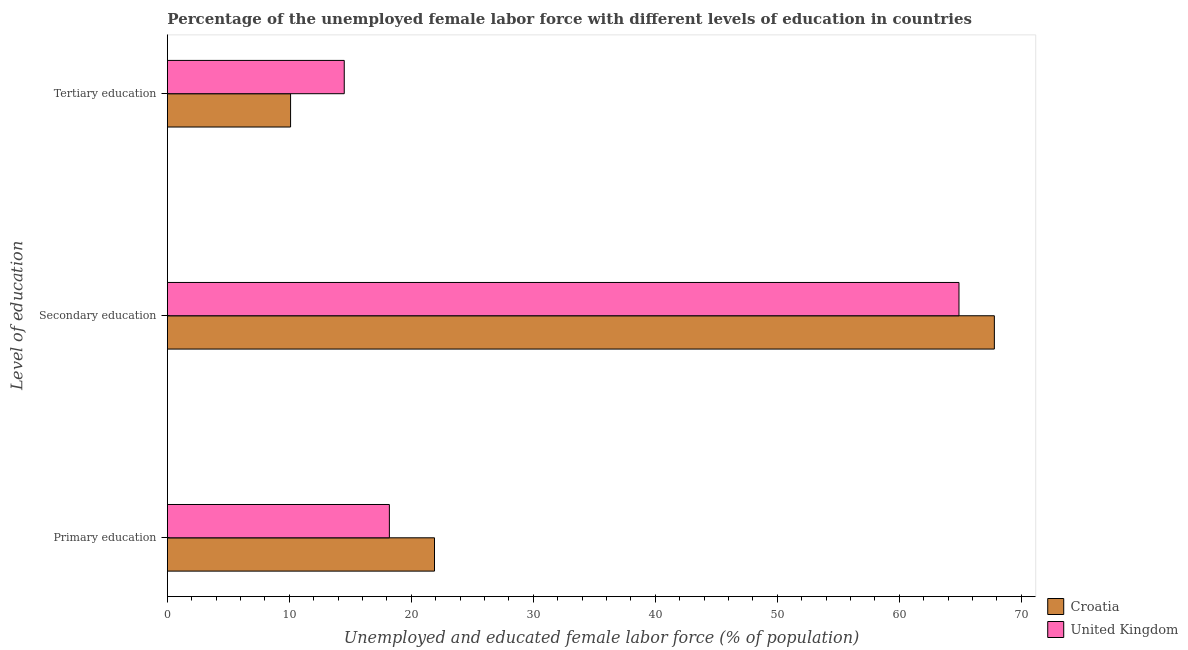How many groups of bars are there?
Ensure brevity in your answer.  3. Are the number of bars per tick equal to the number of legend labels?
Provide a short and direct response. Yes. How many bars are there on the 3rd tick from the bottom?
Provide a succinct answer. 2. What is the label of the 3rd group of bars from the top?
Offer a very short reply. Primary education. What is the percentage of female labor force who received primary education in United Kingdom?
Keep it short and to the point. 18.2. Across all countries, what is the maximum percentage of female labor force who received tertiary education?
Offer a terse response. 14.5. Across all countries, what is the minimum percentage of female labor force who received tertiary education?
Provide a succinct answer. 10.1. In which country was the percentage of female labor force who received primary education maximum?
Give a very brief answer. Croatia. What is the total percentage of female labor force who received tertiary education in the graph?
Give a very brief answer. 24.6. What is the difference between the percentage of female labor force who received tertiary education in United Kingdom and that in Croatia?
Provide a short and direct response. 4.4. What is the difference between the percentage of female labor force who received secondary education in Croatia and the percentage of female labor force who received primary education in United Kingdom?
Keep it short and to the point. 49.6. What is the average percentage of female labor force who received primary education per country?
Your answer should be compact. 20.05. What is the difference between the percentage of female labor force who received secondary education and percentage of female labor force who received tertiary education in Croatia?
Make the answer very short. 57.7. What is the ratio of the percentage of female labor force who received tertiary education in Croatia to that in United Kingdom?
Give a very brief answer. 0.7. What is the difference between the highest and the second highest percentage of female labor force who received primary education?
Your answer should be compact. 3.7. What is the difference between the highest and the lowest percentage of female labor force who received secondary education?
Provide a short and direct response. 2.9. Is the sum of the percentage of female labor force who received tertiary education in United Kingdom and Croatia greater than the maximum percentage of female labor force who received secondary education across all countries?
Give a very brief answer. No. Are all the bars in the graph horizontal?
Offer a very short reply. Yes. How many countries are there in the graph?
Your answer should be very brief. 2. Are the values on the major ticks of X-axis written in scientific E-notation?
Keep it short and to the point. No. Does the graph contain grids?
Provide a short and direct response. No. How many legend labels are there?
Your answer should be very brief. 2. What is the title of the graph?
Your answer should be compact. Percentage of the unemployed female labor force with different levels of education in countries. Does "High income: nonOECD" appear as one of the legend labels in the graph?
Your response must be concise. No. What is the label or title of the X-axis?
Ensure brevity in your answer.  Unemployed and educated female labor force (% of population). What is the label or title of the Y-axis?
Your answer should be very brief. Level of education. What is the Unemployed and educated female labor force (% of population) of Croatia in Primary education?
Provide a succinct answer. 21.9. What is the Unemployed and educated female labor force (% of population) in United Kingdom in Primary education?
Keep it short and to the point. 18.2. What is the Unemployed and educated female labor force (% of population) in Croatia in Secondary education?
Your answer should be very brief. 67.8. What is the Unemployed and educated female labor force (% of population) of United Kingdom in Secondary education?
Ensure brevity in your answer.  64.9. What is the Unemployed and educated female labor force (% of population) in Croatia in Tertiary education?
Your response must be concise. 10.1. Across all Level of education, what is the maximum Unemployed and educated female labor force (% of population) of Croatia?
Your answer should be compact. 67.8. Across all Level of education, what is the maximum Unemployed and educated female labor force (% of population) in United Kingdom?
Provide a short and direct response. 64.9. Across all Level of education, what is the minimum Unemployed and educated female labor force (% of population) in Croatia?
Offer a terse response. 10.1. What is the total Unemployed and educated female labor force (% of population) in Croatia in the graph?
Keep it short and to the point. 99.8. What is the total Unemployed and educated female labor force (% of population) of United Kingdom in the graph?
Your answer should be very brief. 97.6. What is the difference between the Unemployed and educated female labor force (% of population) in Croatia in Primary education and that in Secondary education?
Offer a very short reply. -45.9. What is the difference between the Unemployed and educated female labor force (% of population) of United Kingdom in Primary education and that in Secondary education?
Make the answer very short. -46.7. What is the difference between the Unemployed and educated female labor force (% of population) of Croatia in Secondary education and that in Tertiary education?
Ensure brevity in your answer.  57.7. What is the difference between the Unemployed and educated female labor force (% of population) of United Kingdom in Secondary education and that in Tertiary education?
Ensure brevity in your answer.  50.4. What is the difference between the Unemployed and educated female labor force (% of population) of Croatia in Primary education and the Unemployed and educated female labor force (% of population) of United Kingdom in Secondary education?
Make the answer very short. -43. What is the difference between the Unemployed and educated female labor force (% of population) in Croatia in Primary education and the Unemployed and educated female labor force (% of population) in United Kingdom in Tertiary education?
Give a very brief answer. 7.4. What is the difference between the Unemployed and educated female labor force (% of population) of Croatia in Secondary education and the Unemployed and educated female labor force (% of population) of United Kingdom in Tertiary education?
Make the answer very short. 53.3. What is the average Unemployed and educated female labor force (% of population) of Croatia per Level of education?
Make the answer very short. 33.27. What is the average Unemployed and educated female labor force (% of population) in United Kingdom per Level of education?
Give a very brief answer. 32.53. What is the difference between the Unemployed and educated female labor force (% of population) in Croatia and Unemployed and educated female labor force (% of population) in United Kingdom in Primary education?
Your answer should be compact. 3.7. What is the difference between the Unemployed and educated female labor force (% of population) of Croatia and Unemployed and educated female labor force (% of population) of United Kingdom in Secondary education?
Your answer should be very brief. 2.9. What is the difference between the Unemployed and educated female labor force (% of population) in Croatia and Unemployed and educated female labor force (% of population) in United Kingdom in Tertiary education?
Provide a succinct answer. -4.4. What is the ratio of the Unemployed and educated female labor force (% of population) in Croatia in Primary education to that in Secondary education?
Give a very brief answer. 0.32. What is the ratio of the Unemployed and educated female labor force (% of population) of United Kingdom in Primary education to that in Secondary education?
Your response must be concise. 0.28. What is the ratio of the Unemployed and educated female labor force (% of population) in Croatia in Primary education to that in Tertiary education?
Your response must be concise. 2.17. What is the ratio of the Unemployed and educated female labor force (% of population) of United Kingdom in Primary education to that in Tertiary education?
Your answer should be compact. 1.26. What is the ratio of the Unemployed and educated female labor force (% of population) of Croatia in Secondary education to that in Tertiary education?
Keep it short and to the point. 6.71. What is the ratio of the Unemployed and educated female labor force (% of population) of United Kingdom in Secondary education to that in Tertiary education?
Provide a succinct answer. 4.48. What is the difference between the highest and the second highest Unemployed and educated female labor force (% of population) in Croatia?
Your answer should be very brief. 45.9. What is the difference between the highest and the second highest Unemployed and educated female labor force (% of population) in United Kingdom?
Your answer should be very brief. 46.7. What is the difference between the highest and the lowest Unemployed and educated female labor force (% of population) in Croatia?
Provide a short and direct response. 57.7. What is the difference between the highest and the lowest Unemployed and educated female labor force (% of population) of United Kingdom?
Your answer should be compact. 50.4. 